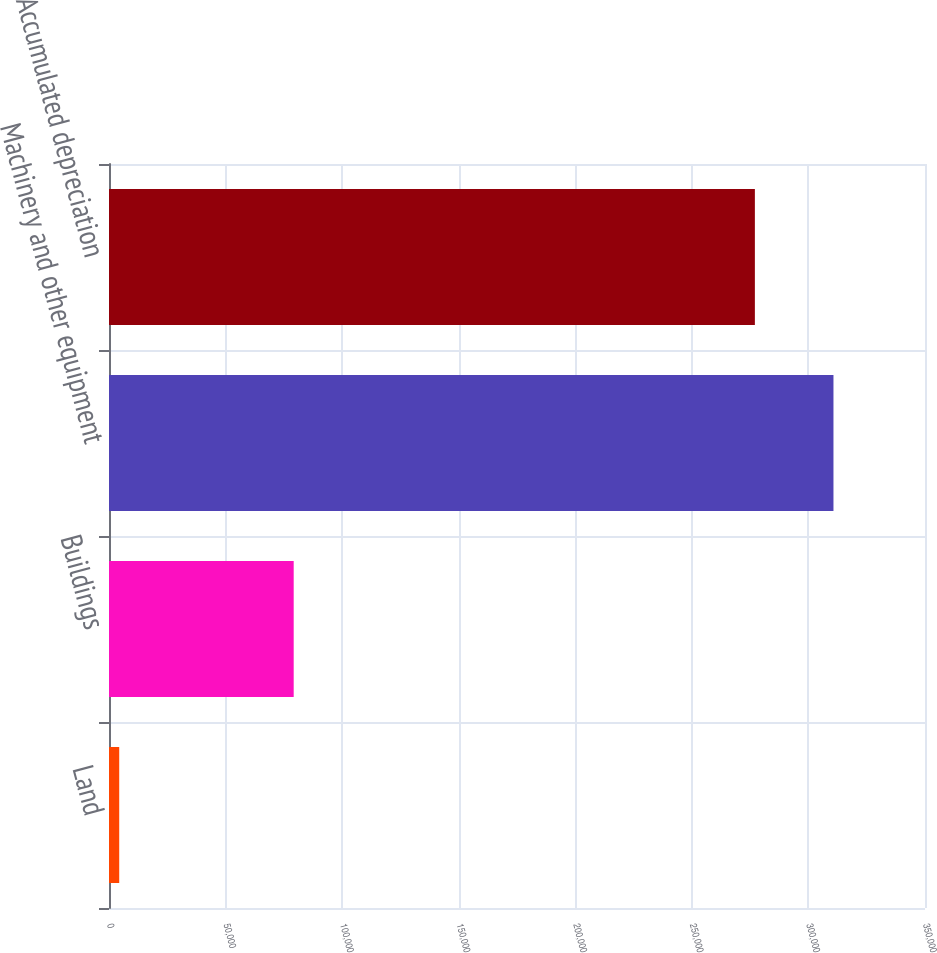Convert chart. <chart><loc_0><loc_0><loc_500><loc_500><bar_chart><fcel>Land<fcel>Buildings<fcel>Machinery and other equipment<fcel>Accumulated depreciation<nl><fcel>4384<fcel>79219<fcel>310738<fcel>277031<nl></chart> 